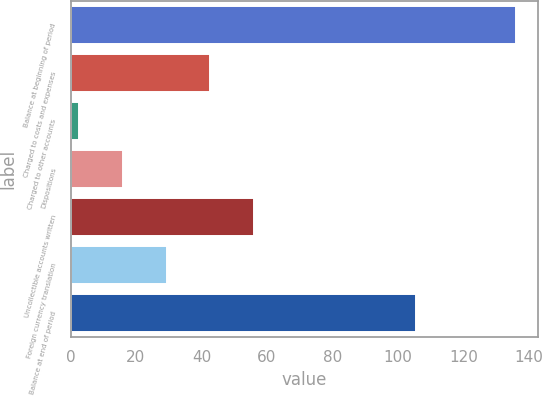Convert chart to OTSL. <chart><loc_0><loc_0><loc_500><loc_500><bar_chart><fcel>Balance at beginning of period<fcel>Charged to costs and expenses<fcel>Charged to other accounts<fcel>Dispositions<fcel>Uncollectible accounts written<fcel>Foreign currency translation<fcel>Balance at end of period<nl><fcel>136.1<fcel>42.72<fcel>2.7<fcel>16.04<fcel>56.06<fcel>29.38<fcel>105.5<nl></chart> 